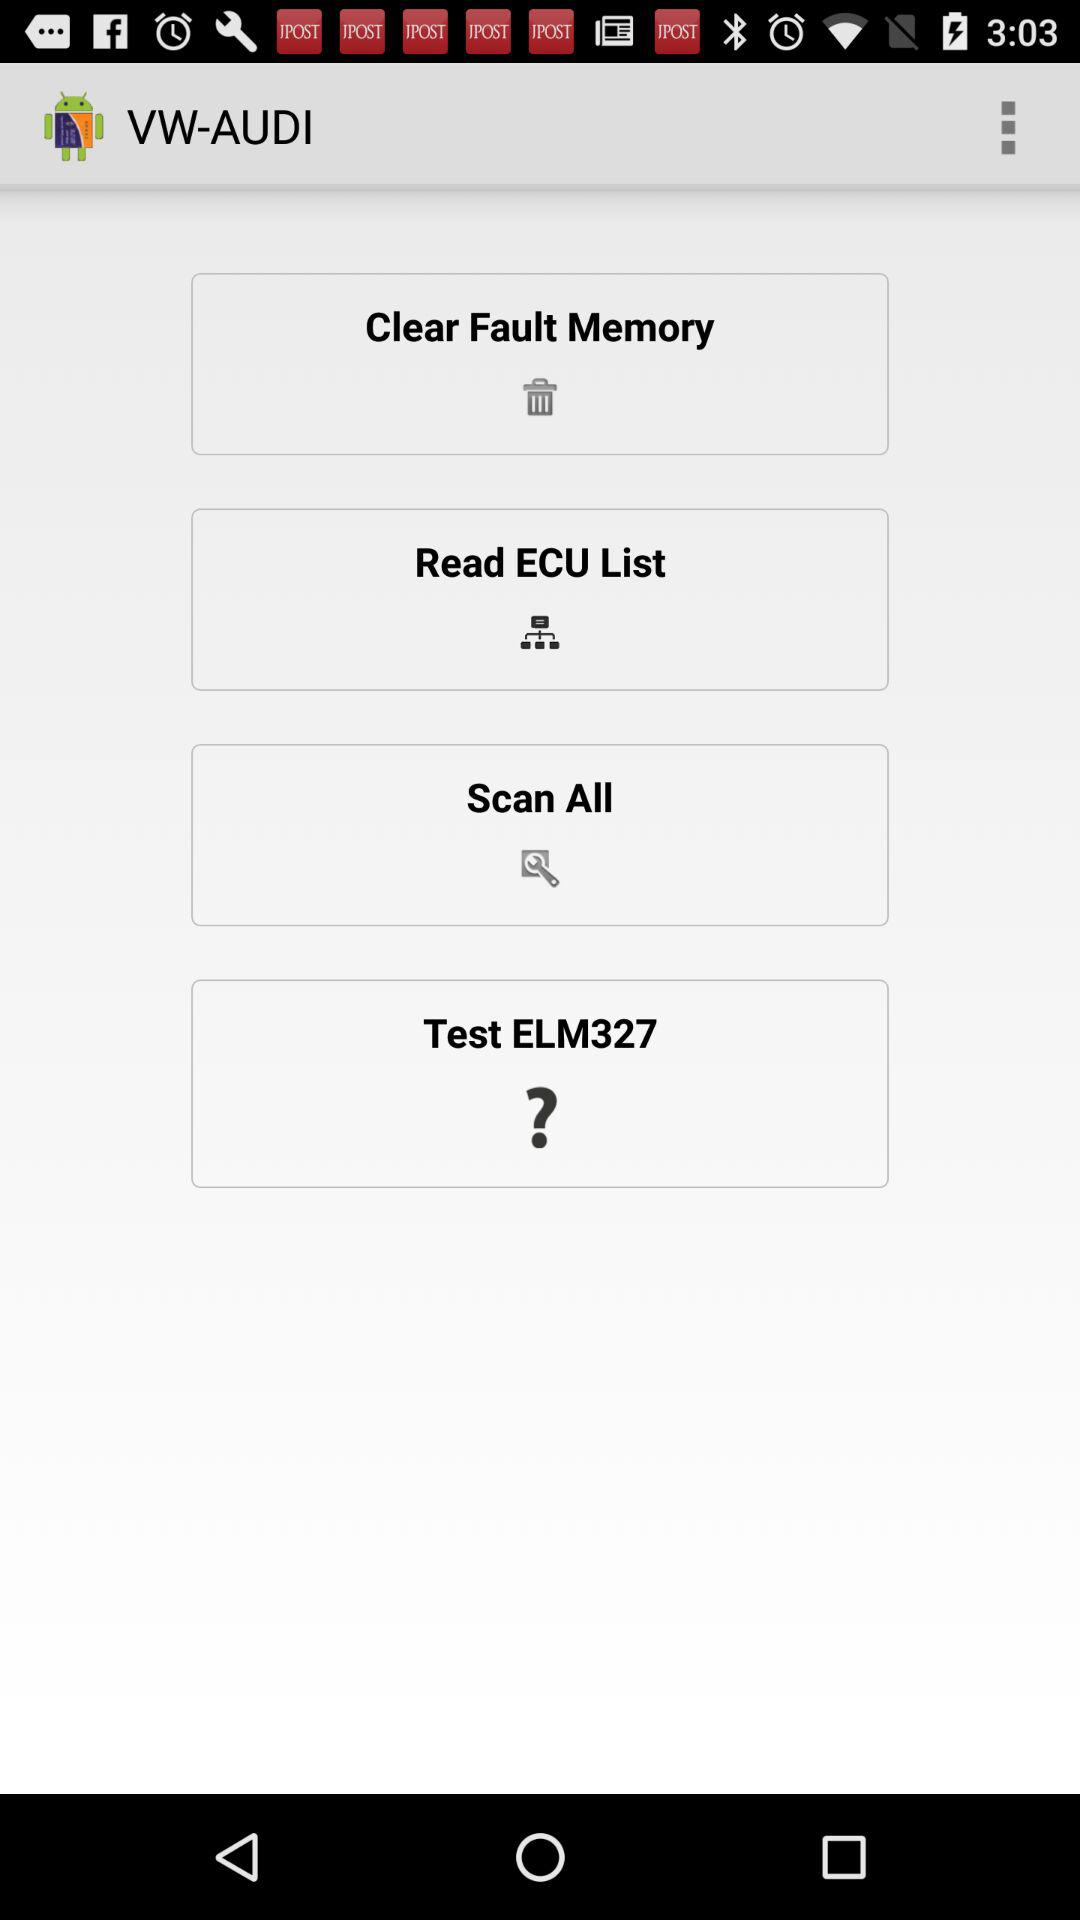What is the name of the application?
When the provided information is insufficient, respond with <no answer>. <no answer> 